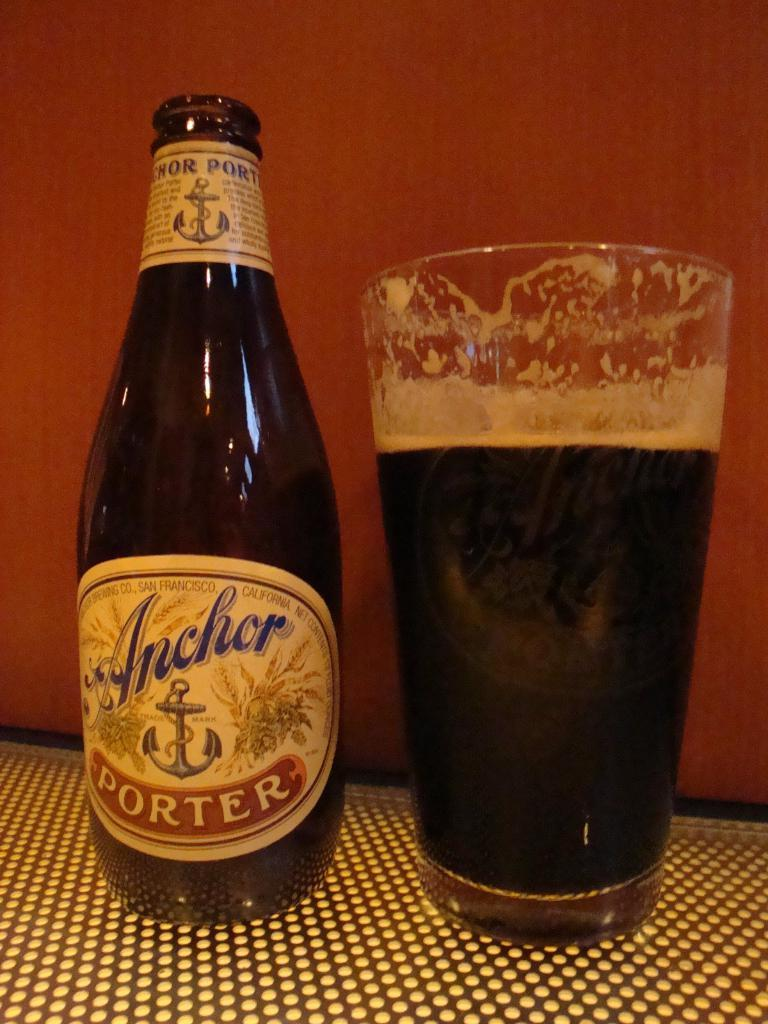<image>
Render a clear and concise summary of the photo. An open bottle of Anchor Porter next to a glass filled with Anchor Porter. 